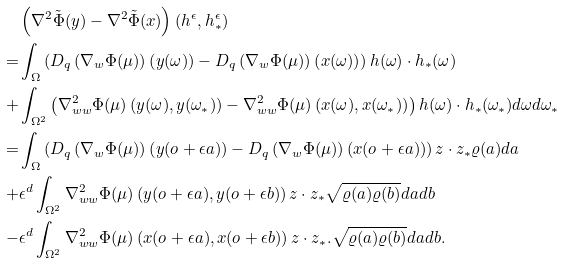Convert formula to latex. <formula><loc_0><loc_0><loc_500><loc_500>& \left ( \nabla ^ { 2 } \tilde { \Phi } ( y ) - \nabla ^ { 2 } \tilde { \Phi } ( x ) \right ) ( h ^ { \epsilon } , h _ { * } ^ { \epsilon } ) \\ = & \int _ { \Omega } \left ( D _ { q } \left ( \nabla _ { w } \Phi ( \mu ) \right ) \left ( y ( \omega ) \right ) - D _ { q } \left ( \nabla _ { w } \Phi ( \mu ) \right ) \left ( x ( \omega ) \right ) \right ) h ( \omega ) \cdot h _ { * } ( \omega ) \\ + & \int _ { \Omega ^ { 2 } } \left ( \nabla ^ { 2 } _ { w w } \Phi ( \mu ) \left ( y ( \omega ) , y ( \omega _ { * } ) \right ) - \nabla ^ { 2 } _ { w w } \Phi ( \mu ) \left ( x ( \omega ) , x ( \omega _ { * } ) \right ) \right ) h ( \omega ) \cdot h _ { * } ( \omega _ { * } ) d \omega d \omega _ { * } \\ = & \int _ { \Omega } \left ( D _ { q } \left ( \nabla _ { w } \Phi ( \mu ) \right ) \left ( y ( o + \epsilon a ) \right ) - D _ { q } \left ( \nabla _ { w } \Phi ( \mu ) \right ) \left ( x ( o + \epsilon a ) \right ) \right ) z \cdot z _ { * } \varrho ( a ) d a \\ + & \epsilon ^ { d } \int _ { \Omega ^ { 2 } } \nabla ^ { 2 } _ { w w } \Phi ( \mu ) \left ( y ( o + \epsilon a ) , y ( o + \epsilon b ) \right ) z \cdot z _ { * } \sqrt { \varrho ( a ) \varrho ( b ) } d a d b \\ - & \epsilon ^ { d } \int _ { \Omega ^ { 2 } } \nabla ^ { 2 } _ { w w } \Phi ( \mu ) \left ( x ( o + \epsilon a ) , x ( o + \epsilon b ) \right ) z \cdot z _ { * } . \sqrt { \varrho ( a ) \varrho ( b ) } d a d b .</formula> 